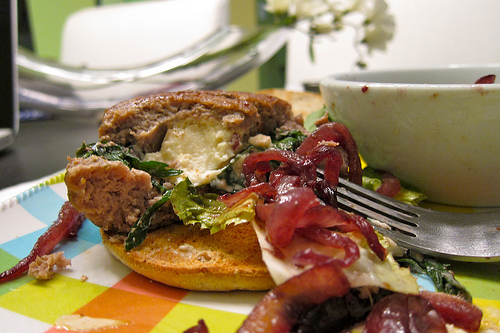<image>
Can you confirm if the fork is in the sandwich? Yes. The fork is contained within or inside the sandwich, showing a containment relationship. 